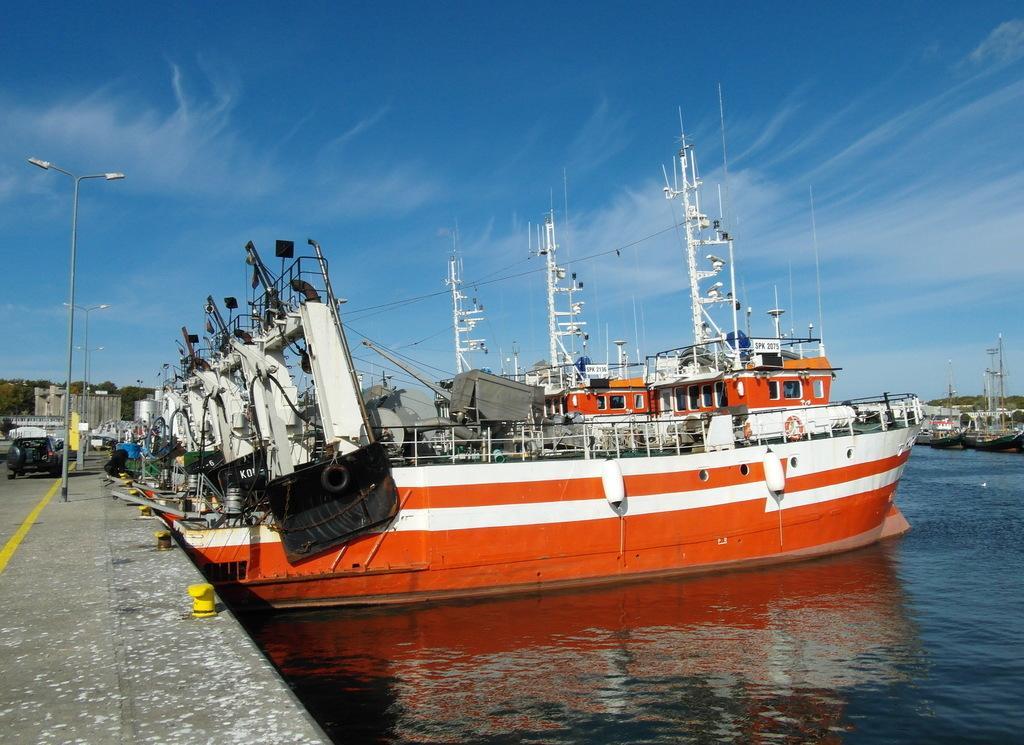Please provide a concise description of this image. In this image, there are ships and in the background, we can see some vehicles, lights and at the bottom, there is water. 